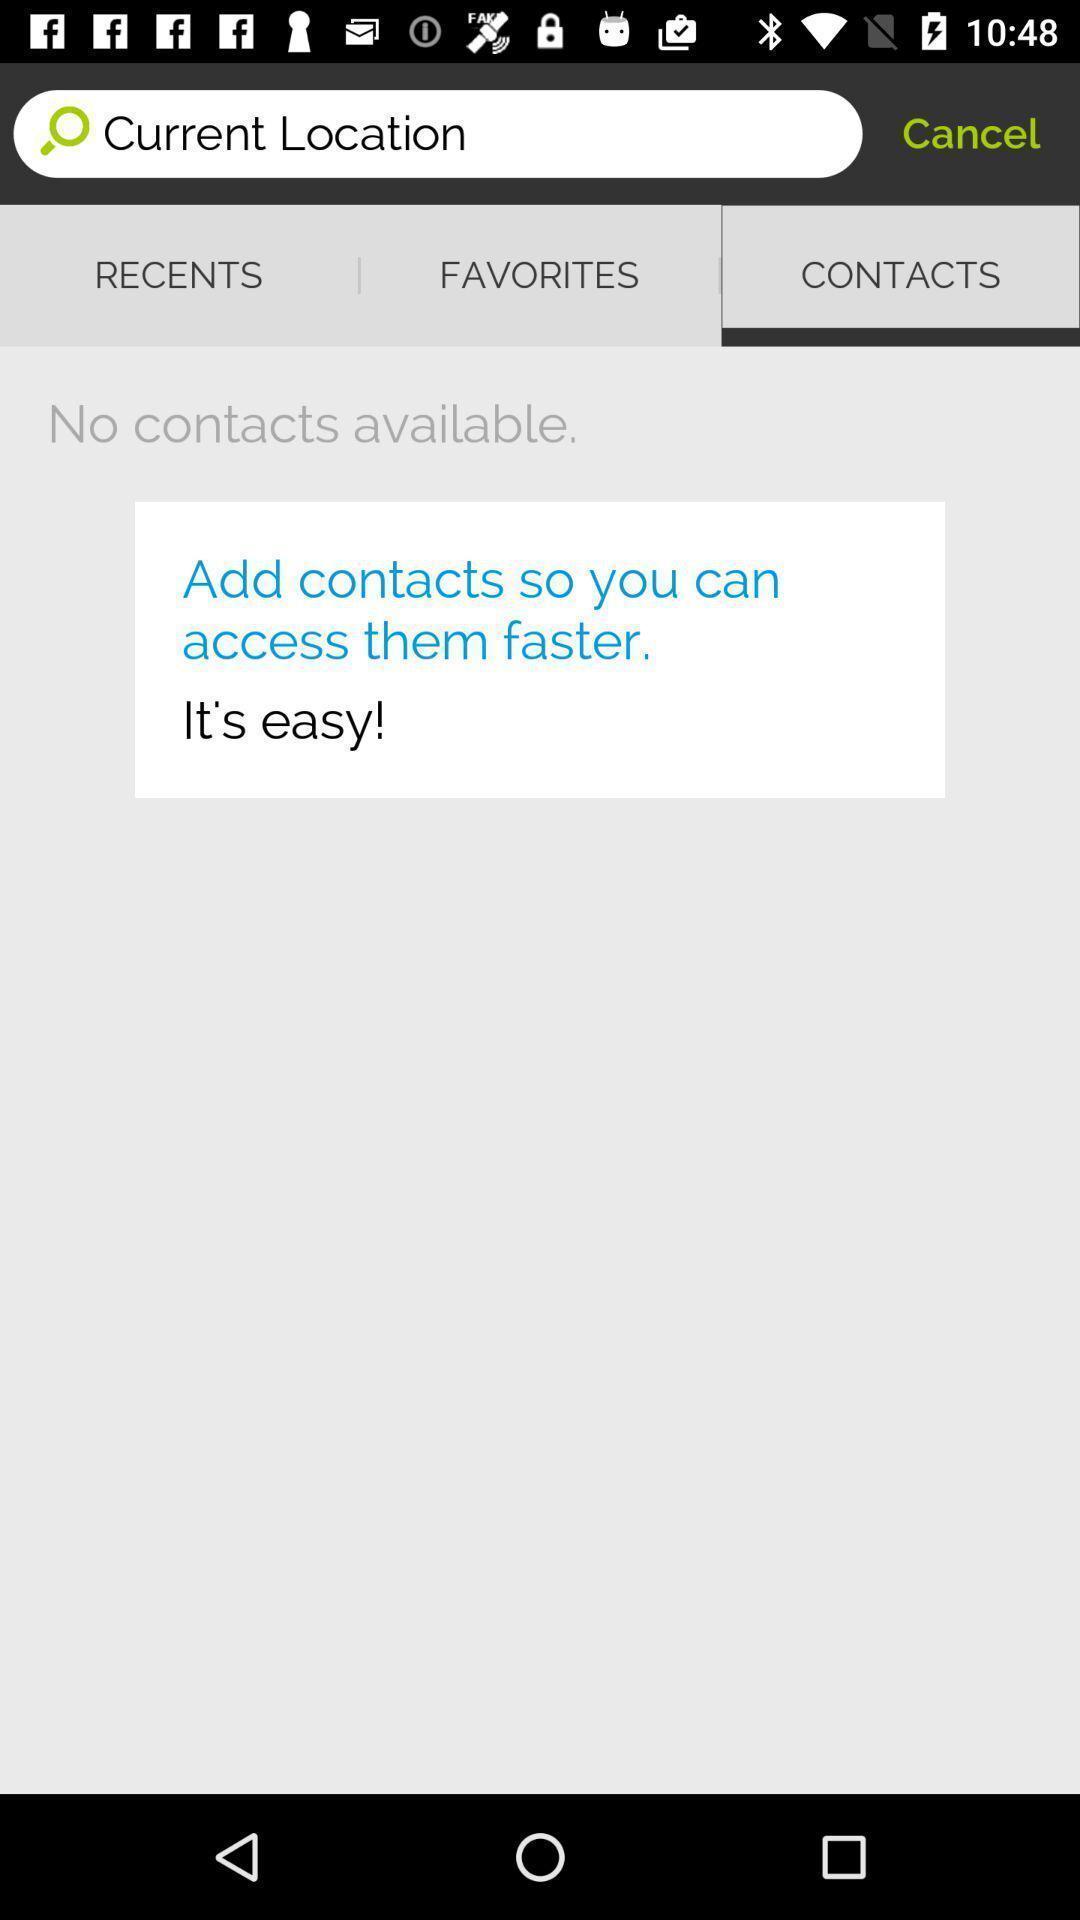Describe this image in words. Page shows to add your contacts. 